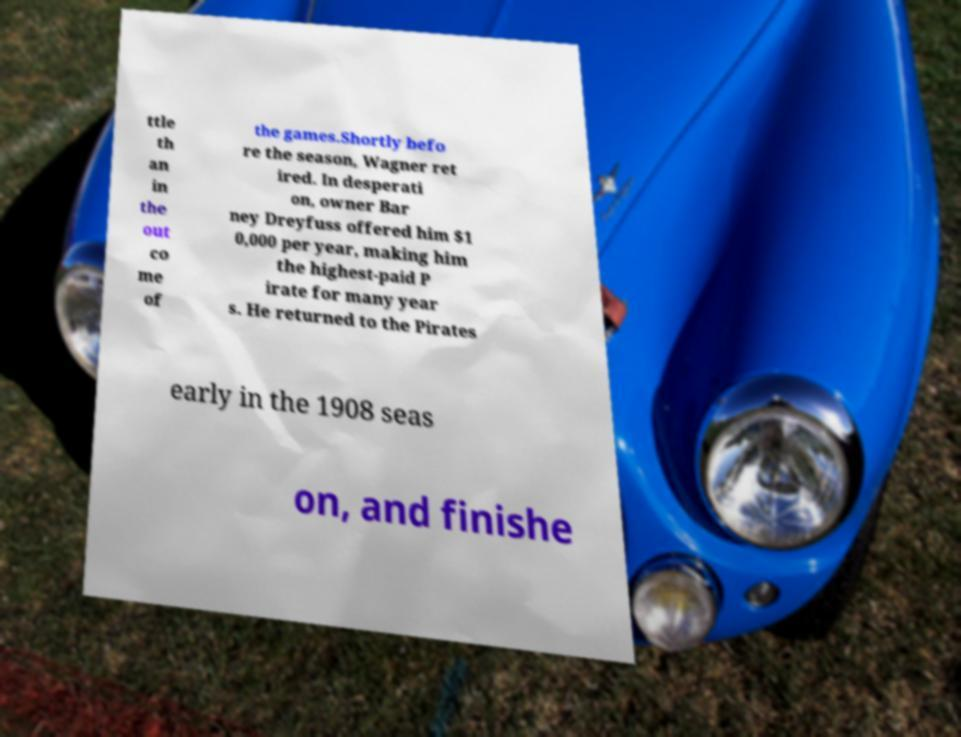For documentation purposes, I need the text within this image transcribed. Could you provide that? ttle th an in the out co me of the games.Shortly befo re the season, Wagner ret ired. In desperati on, owner Bar ney Dreyfuss offered him $1 0,000 per year, making him the highest-paid P irate for many year s. He returned to the Pirates early in the 1908 seas on, and finishe 